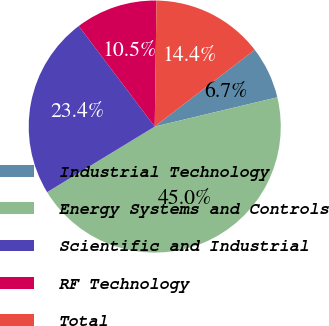Convert chart. <chart><loc_0><loc_0><loc_500><loc_500><pie_chart><fcel>Industrial Technology<fcel>Energy Systems and Controls<fcel>Scientific and Industrial<fcel>RF Technology<fcel>Total<nl><fcel>6.69%<fcel>45.02%<fcel>23.41%<fcel>10.52%<fcel>14.36%<nl></chart> 